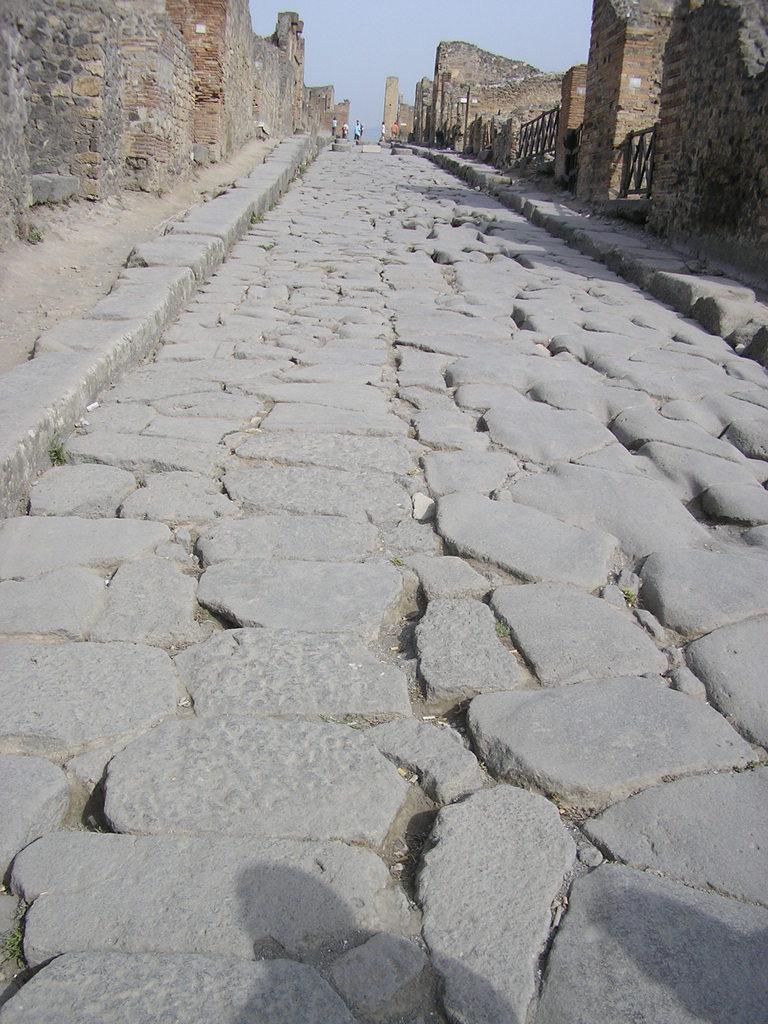Could you give a brief overview of what you see in this image? In the foreground of this image, there is a stone path. On either side, there are walls. On the right, there are few railings. In the background, there are few people and the sky. 